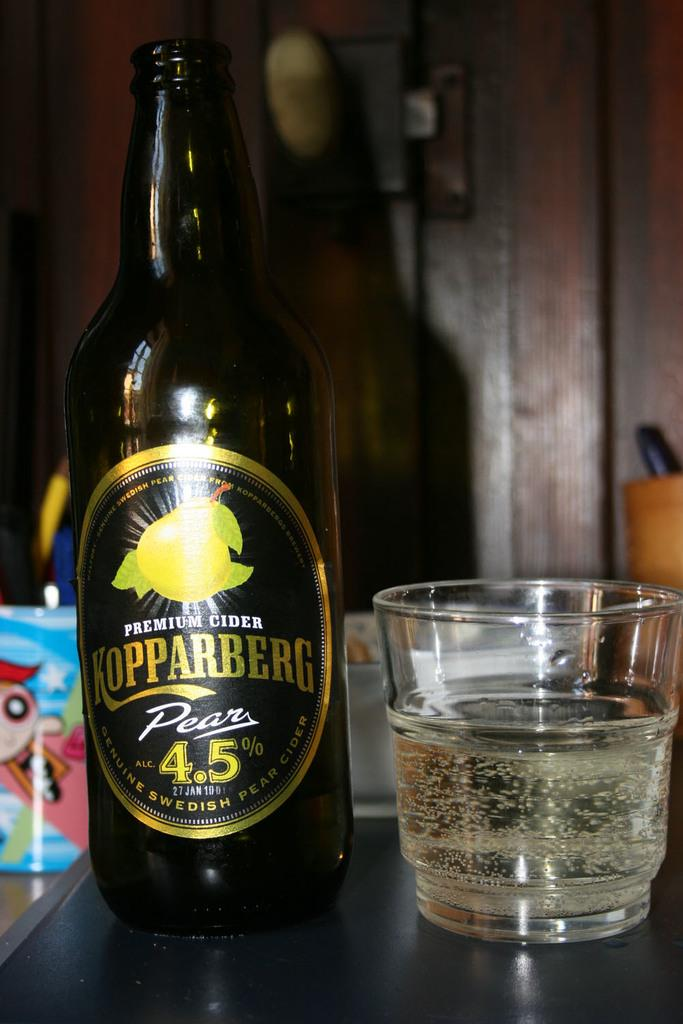<image>
Provide a brief description of the given image. A glass with a sparking liquid in it sits next to a bottle of Kopparberg cider. 